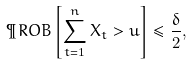<formula> <loc_0><loc_0><loc_500><loc_500>\P R O B \left [ \sum _ { t = 1 } ^ { n } X _ { t } > u \right ] \leq \frac { \delta } { 2 } ,</formula> 